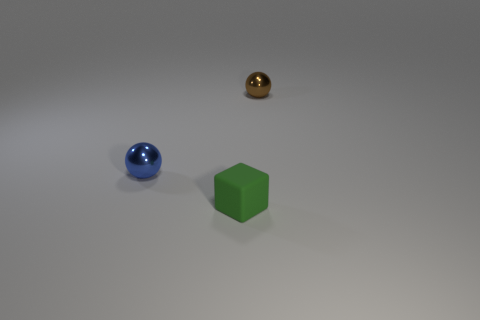Is the tiny green object the same shape as the blue thing?
Your answer should be compact. No. What number of cubes are large red metal objects or tiny things?
Offer a terse response. 1. What is the color of the small sphere that is the same material as the tiny brown thing?
Give a very brief answer. Blue. Does the tiny blue sphere have the same material as the small thing that is in front of the tiny blue metal object?
Ensure brevity in your answer.  No. There is a tiny metal thing that is right of the blue sphere; what is its color?
Offer a terse response. Brown. There is a metallic ball that is left of the brown thing; is there a green matte cube that is left of it?
Your answer should be very brief. No. There is a brown sphere; how many balls are on the left side of it?
Your answer should be very brief. 1. How many tiny things are the same color as the rubber block?
Provide a succinct answer. 0. Is the sphere that is in front of the small brown object made of the same material as the small brown ball?
Offer a terse response. Yes. How many small objects are made of the same material as the brown sphere?
Offer a very short reply. 1. 